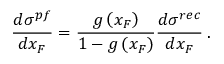Convert formula to latex. <formula><loc_0><loc_0><loc_500><loc_500>\frac { d \sigma ^ { p f } } { d x _ { F } } = \frac { g \left ( x _ { F } \right ) } { 1 - g \left ( x _ { F } \right ) } \frac { d \sigma ^ { r e c } } { d x _ { F } } \, .</formula> 